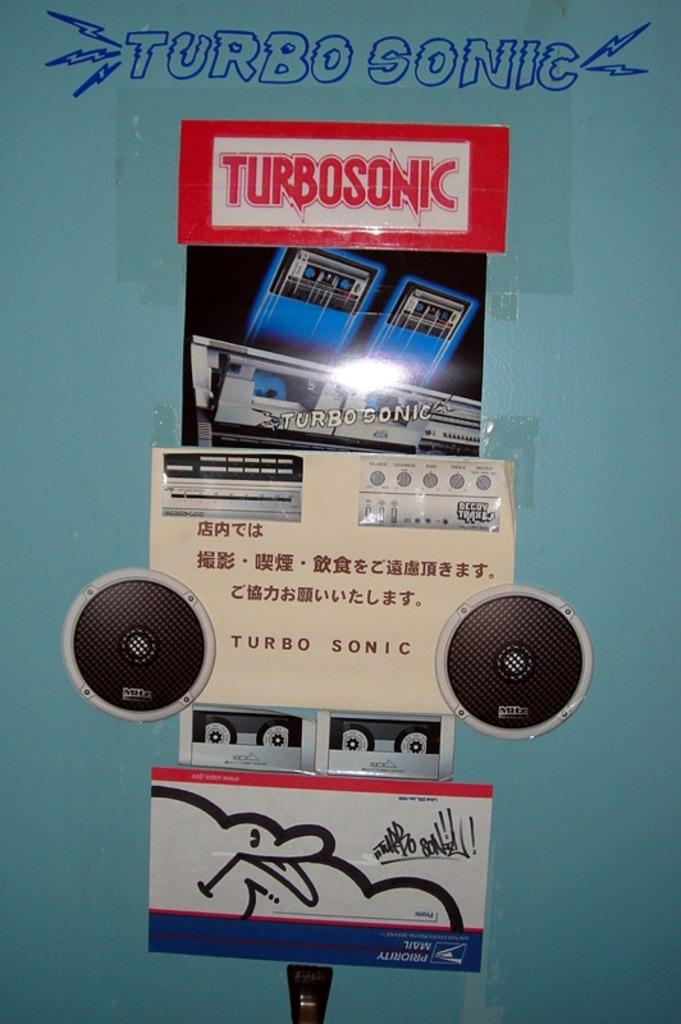Provide a one-sentence caption for the provided image. Someone has written Turbo Sonic on the wall in blue ink. 